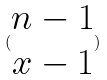<formula> <loc_0><loc_0><loc_500><loc_500>( \begin{matrix} n - 1 \\ x - 1 \end{matrix} )</formula> 